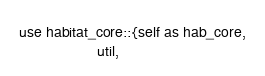<code> <loc_0><loc_0><loc_500><loc_500><_Rust_>use habitat_core::{self as hab_core,
                   util,</code> 